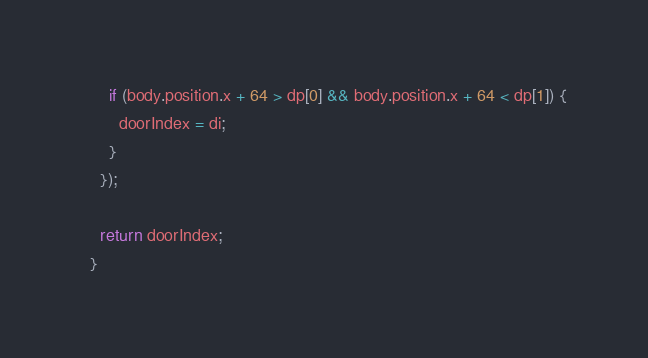Convert code to text. <code><loc_0><loc_0><loc_500><loc_500><_JavaScript_>      if (body.position.x + 64 > dp[0] && body.position.x + 64 < dp[1]) {
        doorIndex = di;
      }
    });

    return doorIndex;
  }
</code> 